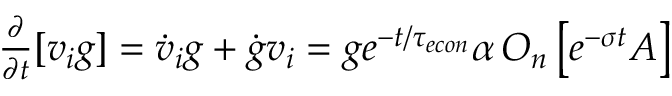Convert formula to latex. <formula><loc_0><loc_0><loc_500><loc_500>\begin{array} { r } { \frac { \partial } { \partial t } [ v _ { i } g ] = \dot { v } _ { i } g + \dot { g } v _ { i } = g e ^ { - t / { \tau _ { e c o n } } } \alpha \, O _ { n } \left [ e ^ { - \sigma t } A \right ] } \end{array}</formula> 